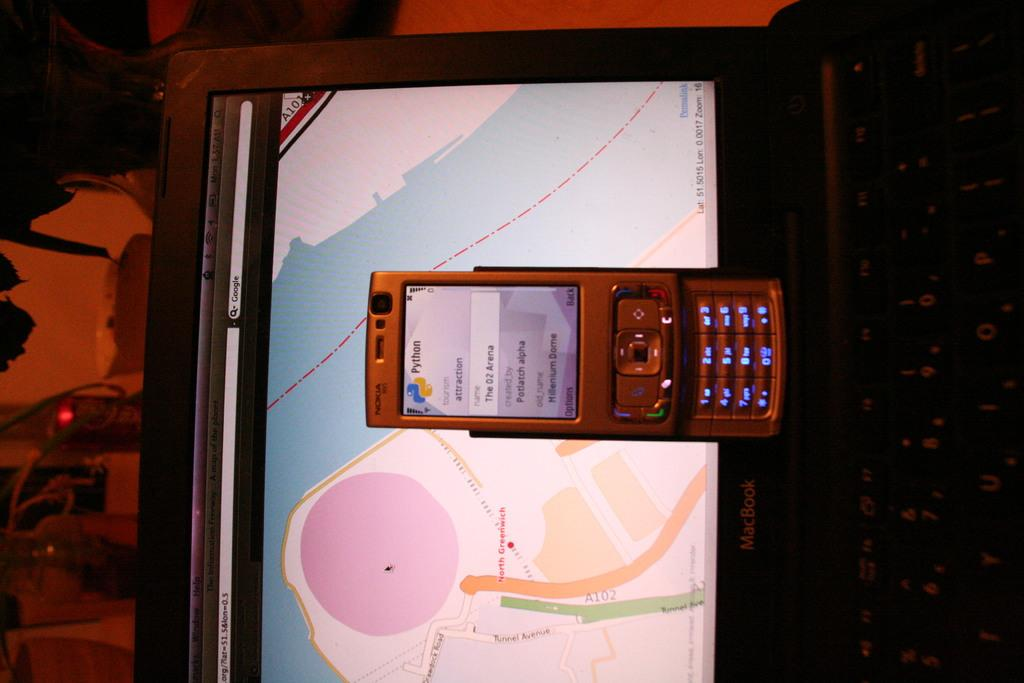Provide a one-sentence caption for the provided image. A cell phone sitting on a laptop displaying a map or Greenwich. 